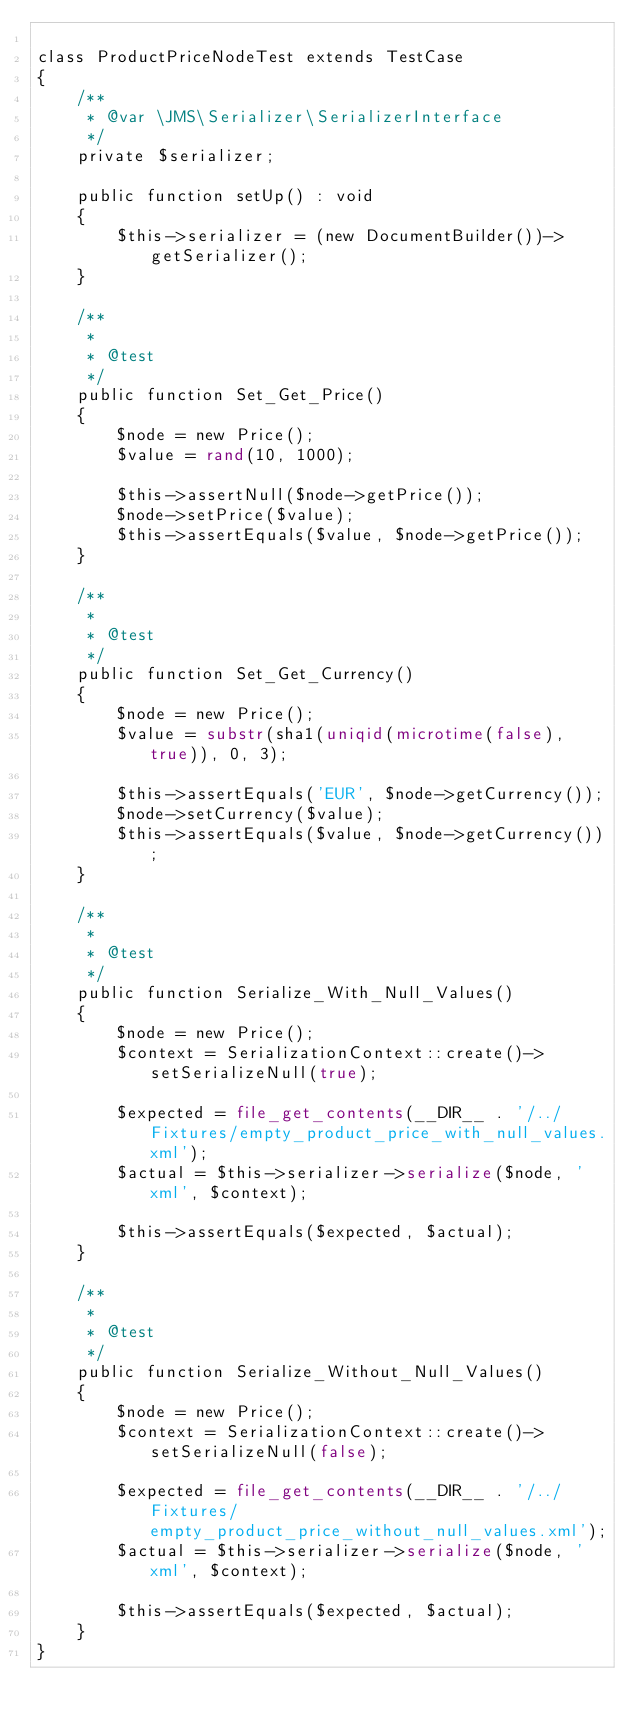<code> <loc_0><loc_0><loc_500><loc_500><_PHP_>
class ProductPriceNodeTest extends TestCase
{
    /**
     * @var \JMS\Serializer\SerializerInterface
     */
    private $serializer;

    public function setUp() : void
    {
        $this->serializer = (new DocumentBuilder())->getSerializer();
    }

    /**
     *
     * @test
     */
    public function Set_Get_Price()
    {
        $node = new Price();
        $value = rand(10, 1000);

        $this->assertNull($node->getPrice());
        $node->setPrice($value);
        $this->assertEquals($value, $node->getPrice());
    }

    /**
     *
     * @test
     */
    public function Set_Get_Currency()
    {
        $node = new Price();
        $value = substr(sha1(uniqid(microtime(false), true)), 0, 3);

        $this->assertEquals('EUR', $node->getCurrency());
        $node->setCurrency($value);
        $this->assertEquals($value, $node->getCurrency());
    }

    /**
     *
     * @test
     */
    public function Serialize_With_Null_Values()
    {
        $node = new Price();
        $context = SerializationContext::create()->setSerializeNull(true);

        $expected = file_get_contents(__DIR__ . '/../Fixtures/empty_product_price_with_null_values.xml');
        $actual = $this->serializer->serialize($node, 'xml', $context);

        $this->assertEquals($expected, $actual);
    }

    /**
     *
     * @test
     */
    public function Serialize_Without_Null_Values()
    {
        $node = new Price();
        $context = SerializationContext::create()->setSerializeNull(false);

        $expected = file_get_contents(__DIR__ . '/../Fixtures/empty_product_price_without_null_values.xml');
        $actual = $this->serializer->serialize($node, 'xml', $context);

        $this->assertEquals($expected, $actual);
    }
}
</code> 